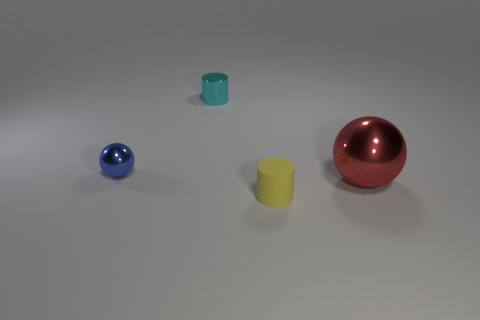There is a yellow thing that is the same size as the cyan metallic cylinder; what shape is it?
Make the answer very short. Cylinder. What is the color of the big metallic ball in front of the sphere that is on the left side of the large red ball?
Make the answer very short. Red. Are there any large shiny balls that are to the left of the metallic sphere on the left side of the small cylinder that is behind the blue metal object?
Your answer should be compact. No. There is a tiny ball that is the same material as the big red object; what is its color?
Your answer should be compact. Blue. How many tiny objects have the same material as the big ball?
Offer a terse response. 2. Is the material of the big ball the same as the object behind the tiny sphere?
Ensure brevity in your answer.  Yes. How many things are either tiny cylinders behind the tiny matte cylinder or tiny blue things?
Provide a succinct answer. 2. There is a metal sphere to the right of the cylinder behind the ball that is right of the tiny ball; what size is it?
Give a very brief answer. Large. What size is the metallic object right of the cylinder to the right of the tiny metal cylinder?
Keep it short and to the point. Large. How many big objects are spheres or cyan matte things?
Your answer should be compact. 1. 